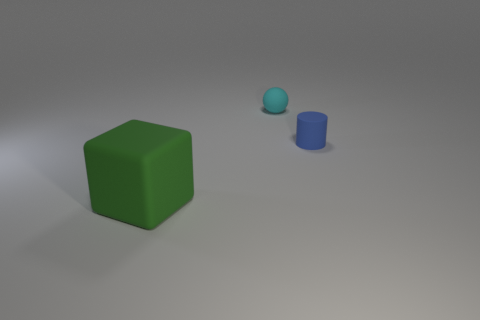There is a matte thing that is left of the cyan sphere; is its color the same as the cylinder?
Make the answer very short. No. Is the material of the cube the same as the cyan sphere?
Keep it short and to the point. Yes. Are there an equal number of matte cubes that are to the left of the big green rubber cube and things behind the small blue cylinder?
Provide a short and direct response. No. There is a matte thing that is behind the small matte object to the right of the small rubber thing behind the blue cylinder; what is its shape?
Your answer should be compact. Sphere. Is the number of small balls behind the large green thing greater than the number of green matte objects?
Keep it short and to the point. No. Do the rubber object that is to the right of the small ball and the big green matte thing have the same shape?
Offer a terse response. No. There is a object behind the tiny blue matte thing; what is it made of?
Your response must be concise. Rubber. What is the material of the object that is to the left of the small object that is to the left of the blue cylinder?
Offer a very short reply. Rubber. Is there a big thing that has the same material as the blue cylinder?
Offer a terse response. Yes. What shape is the blue thing?
Make the answer very short. Cylinder. 